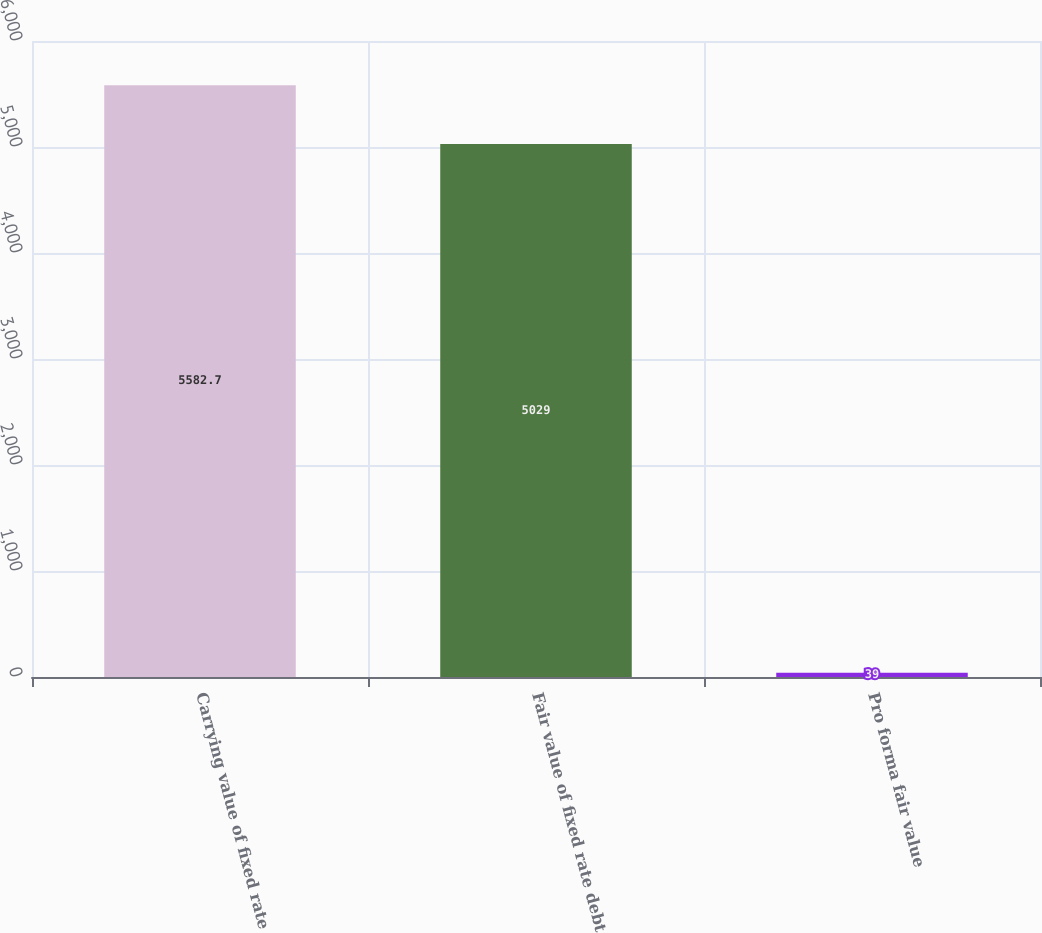<chart> <loc_0><loc_0><loc_500><loc_500><bar_chart><fcel>Carrying value of fixed rate<fcel>Fair value of fixed rate debt<fcel>Pro forma fair value<nl><fcel>5582.7<fcel>5029<fcel>39<nl></chart> 